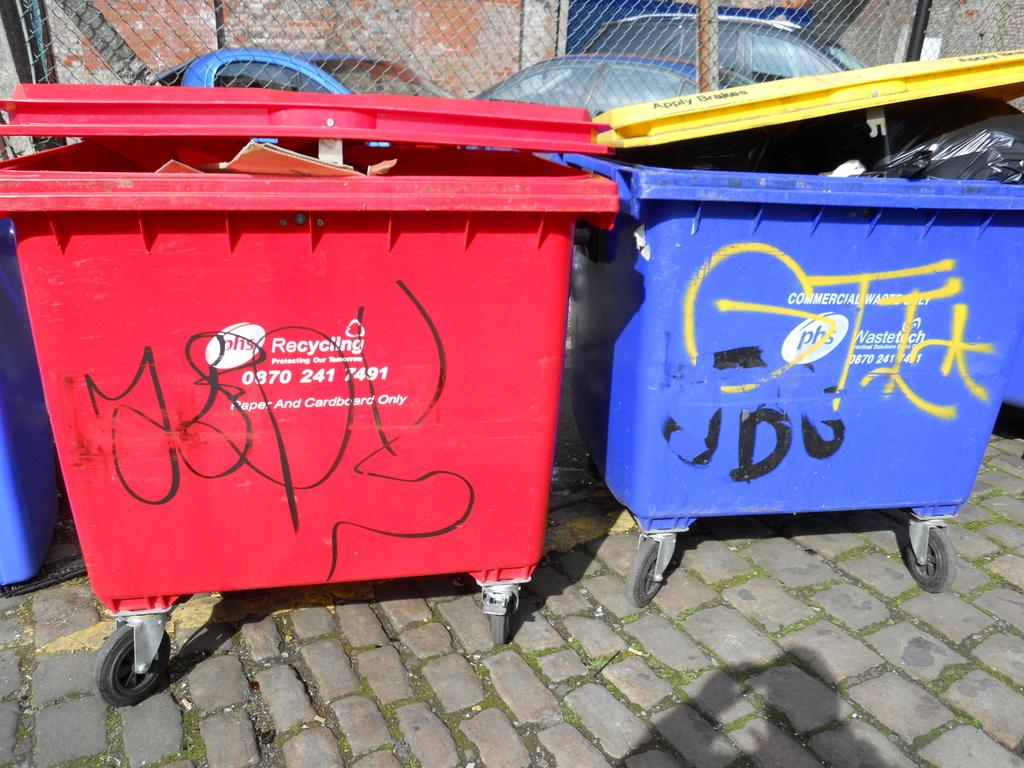<image>
Offer a succinct explanation of the picture presented. A red bin says "Recycling" on the side and it is next to a blue bin. 